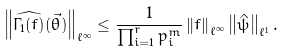Convert formula to latex. <formula><loc_0><loc_0><loc_500><loc_500>\left \| \widehat { \Gamma _ { 1 } ( f ) } ( \vec { \theta } ) \right \| _ { \ell ^ { \infty } } \leq \frac { 1 } { \prod _ { i = 1 } ^ { r } p _ { i } ^ { m } } \left \| f \right \| _ { \ell ^ { \infty } } \left \| \hat { \psi } \right \| _ { \ell ^ { 1 } } .</formula> 